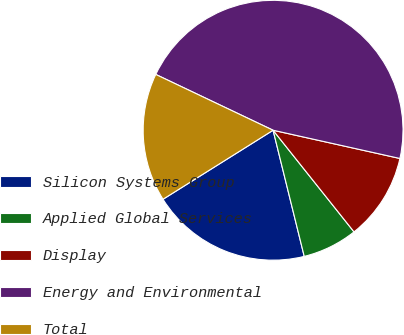Convert chart to OTSL. <chart><loc_0><loc_0><loc_500><loc_500><pie_chart><fcel>Silicon Systems Group<fcel>Applied Global Services<fcel>Display<fcel>Energy and Environmental<fcel>Total<nl><fcel>19.94%<fcel>6.85%<fcel>10.81%<fcel>46.42%<fcel>15.98%<nl></chart> 